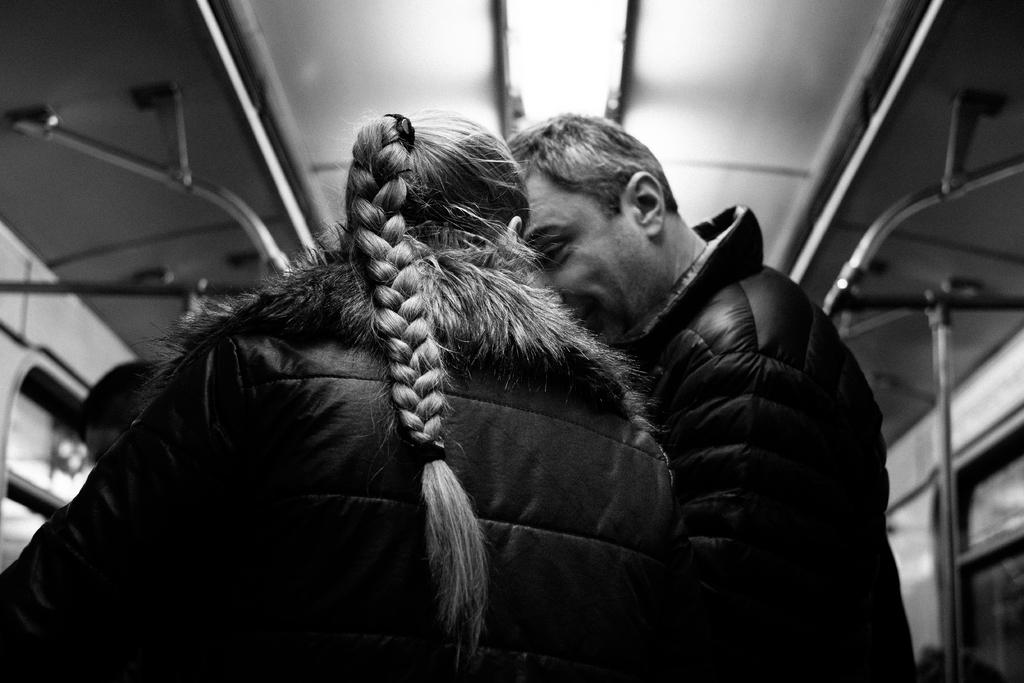How many people are in the image? There are persons in the image, but the exact number is not specified. What can be seen in the background of the image? There is a roof and rods in the background of the image. What type of health issues are the persons in the image experiencing? There is no information about the health of the persons in the image, so it cannot be determined from the image. 